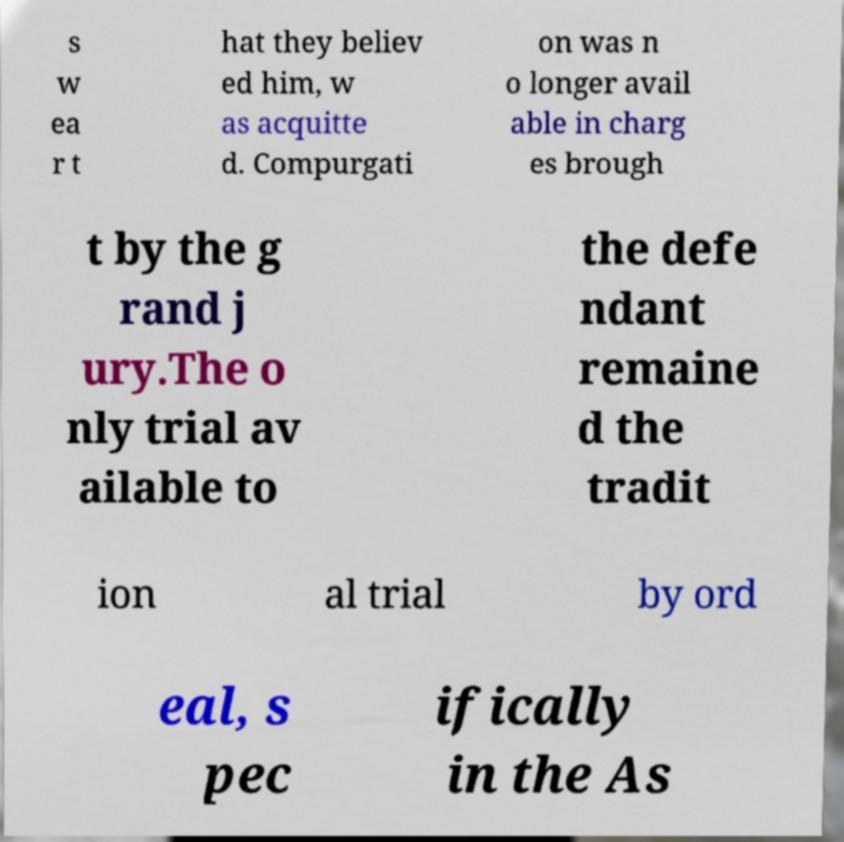Please identify and transcribe the text found in this image. s w ea r t hat they believ ed him, w as acquitte d. Compurgati on was n o longer avail able in charg es brough t by the g rand j ury.The o nly trial av ailable to the defe ndant remaine d the tradit ion al trial by ord eal, s pec ifically in the As 